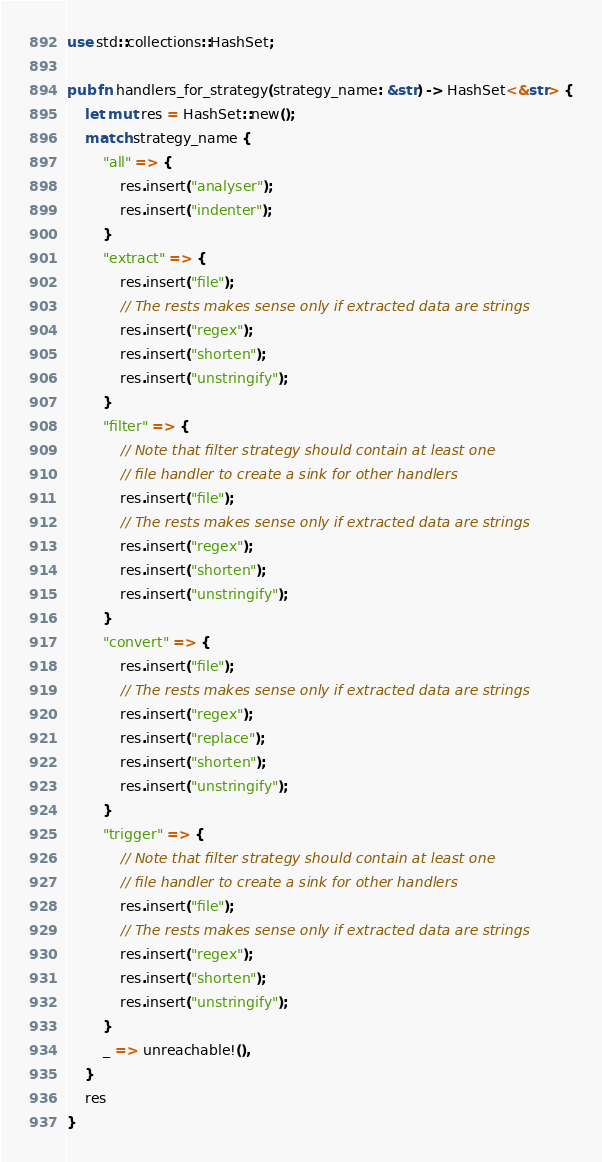<code> <loc_0><loc_0><loc_500><loc_500><_Rust_>use std::collections::HashSet;

pub fn handlers_for_strategy(strategy_name: &str) -> HashSet<&str> {
    let mut res = HashSet::new();
    match strategy_name {
        "all" => {
            res.insert("analyser");
            res.insert("indenter");
        }
        "extract" => {
            res.insert("file");
            // The rests makes sense only if extracted data are strings
            res.insert("regex");
            res.insert("shorten");
            res.insert("unstringify");
        }
        "filter" => {
            // Note that filter strategy should contain at least one
            // file handler to create a sink for other handlers
            res.insert("file");
            // The rests makes sense only if extracted data are strings
            res.insert("regex");
            res.insert("shorten");
            res.insert("unstringify");
        }
        "convert" => {
            res.insert("file");
            // The rests makes sense only if extracted data are strings
            res.insert("regex");
            res.insert("replace");
            res.insert("shorten");
            res.insert("unstringify");
        }
        "trigger" => {
            // Note that filter strategy should contain at least one
            // file handler to create a sink for other handlers
            res.insert("file");
            // The rests makes sense only if extracted data are strings
            res.insert("regex");
            res.insert("shorten");
            res.insert("unstringify");
        }
        _ => unreachable!(),
    }
    res
}
</code> 